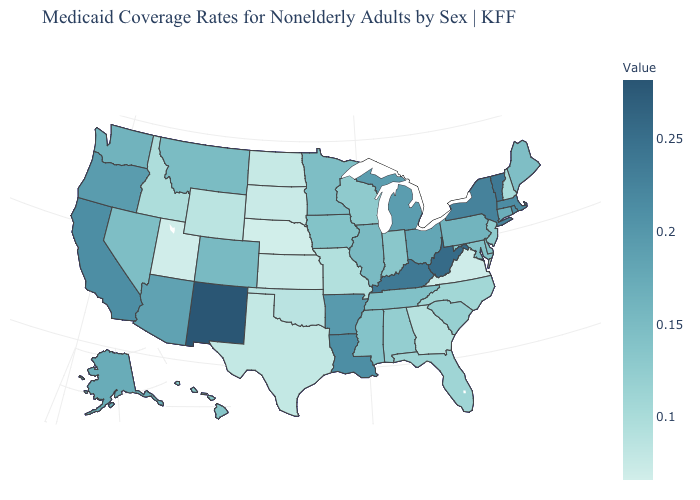Is the legend a continuous bar?
Short answer required. Yes. Does New Hampshire have the lowest value in the Northeast?
Concise answer only. Yes. Among the states that border Rhode Island , does Massachusetts have the lowest value?
Short answer required. No. 